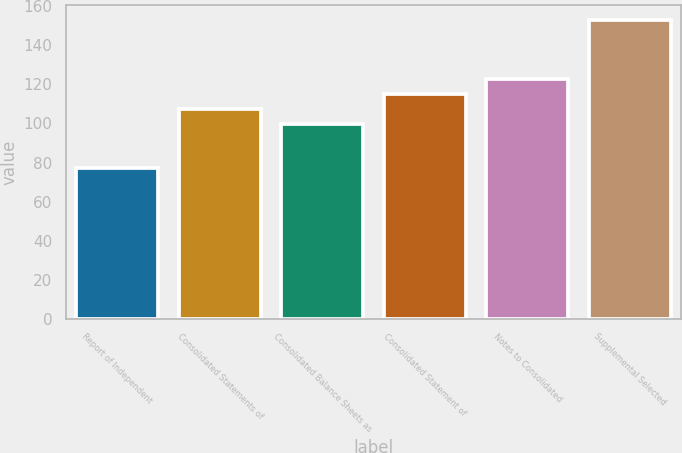Convert chart to OTSL. <chart><loc_0><loc_0><loc_500><loc_500><bar_chart><fcel>Report of Independent<fcel>Consolidated Statements of<fcel>Consolidated Balance Sheets as<fcel>Consolidated Statement of<fcel>Notes to Consolidated<fcel>Supplemental Selected<nl><fcel>77<fcel>107.4<fcel>99.8<fcel>115<fcel>122.6<fcel>153<nl></chart> 